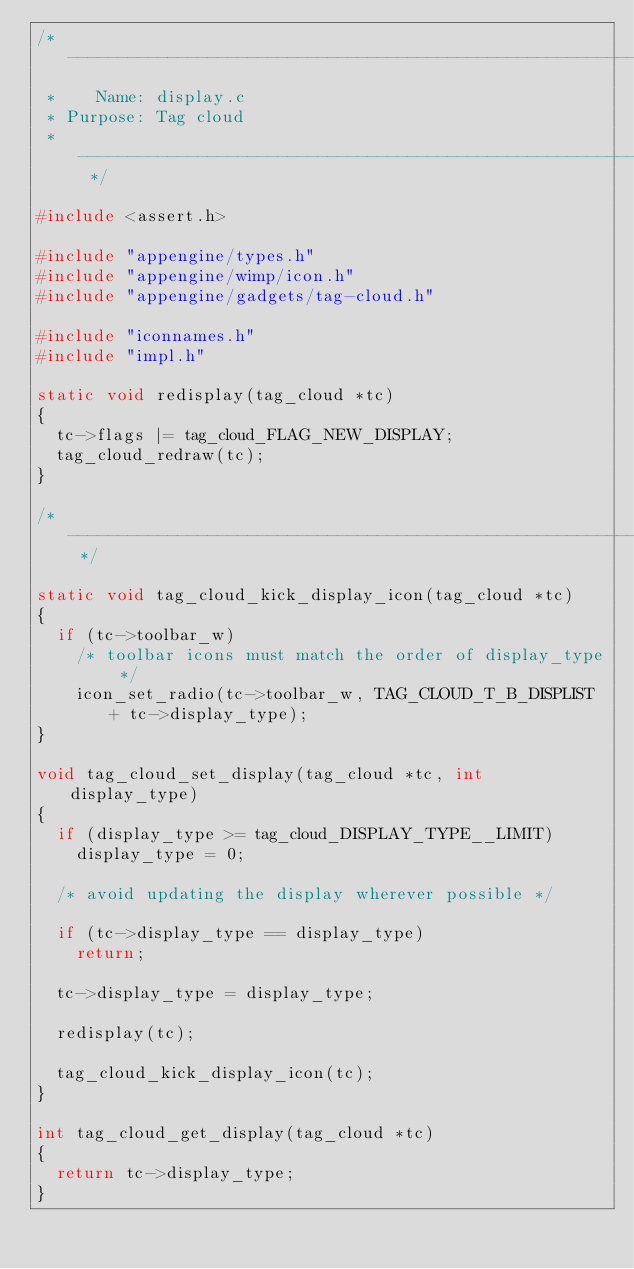<code> <loc_0><loc_0><loc_500><loc_500><_C_>/* --------------------------------------------------------------------------
 *    Name: display.c
 * Purpose: Tag cloud
 * ----------------------------------------------------------------------- */

#include <assert.h>

#include "appengine/types.h"
#include "appengine/wimp/icon.h"
#include "appengine/gadgets/tag-cloud.h"

#include "iconnames.h"
#include "impl.h"

static void redisplay(tag_cloud *tc)
{
  tc->flags |= tag_cloud_FLAG_NEW_DISPLAY;
  tag_cloud_redraw(tc);
}

/* ----------------------------------------------------------------------- */

static void tag_cloud_kick_display_icon(tag_cloud *tc)
{
  if (tc->toolbar_w)
    /* toolbar icons must match the order of display_type */
    icon_set_radio(tc->toolbar_w, TAG_CLOUD_T_B_DISPLIST + tc->display_type);
}

void tag_cloud_set_display(tag_cloud *tc, int display_type)
{
  if (display_type >= tag_cloud_DISPLAY_TYPE__LIMIT)
    display_type = 0;

  /* avoid updating the display wherever possible */

  if (tc->display_type == display_type)
    return;

  tc->display_type = display_type;

  redisplay(tc);

  tag_cloud_kick_display_icon(tc);
}

int tag_cloud_get_display(tag_cloud *tc)
{
  return tc->display_type;
}
</code> 